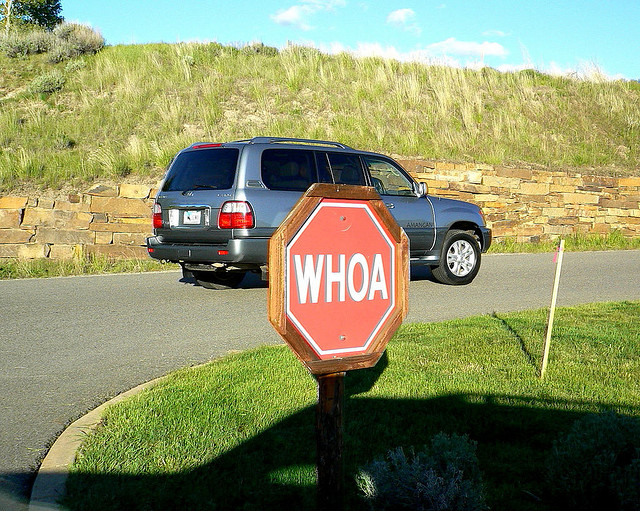Please transcribe the text information in this image. WHOA 